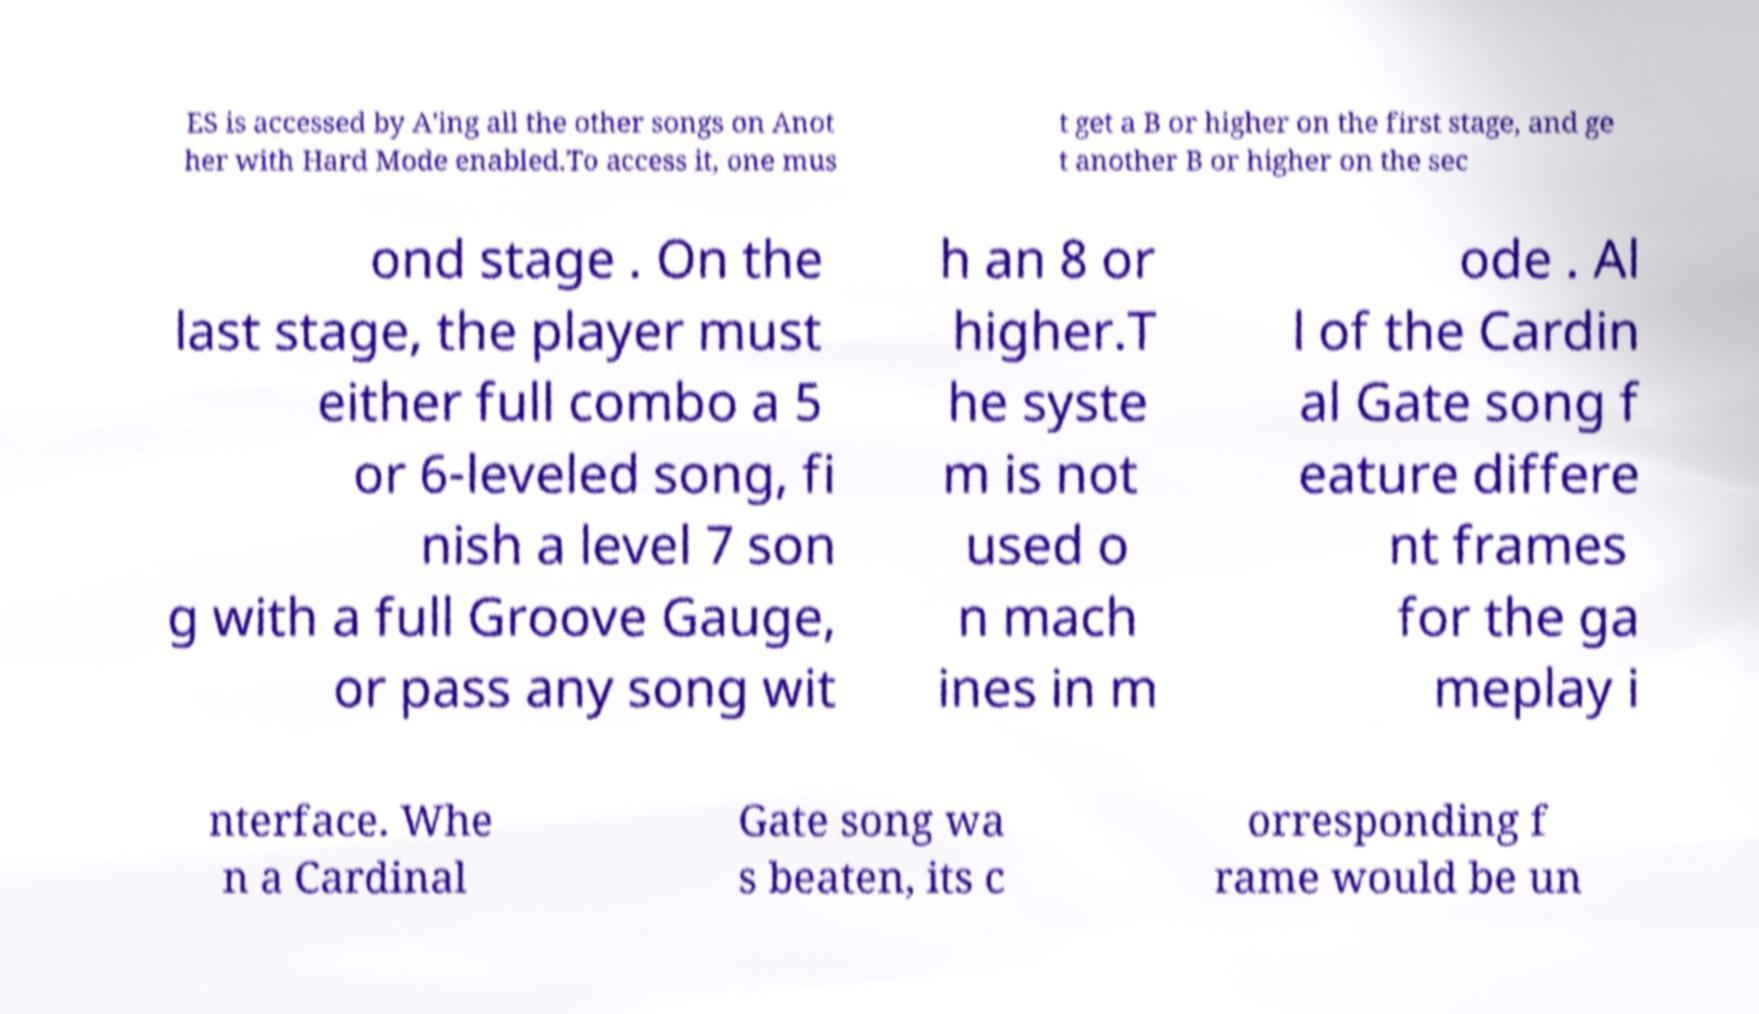Could you assist in decoding the text presented in this image and type it out clearly? ES is accessed by A'ing all the other songs on Anot her with Hard Mode enabled.To access it, one mus t get a B or higher on the first stage, and ge t another B or higher on the sec ond stage . On the last stage, the player must either full combo a 5 or 6-leveled song, fi nish a level 7 son g with a full Groove Gauge, or pass any song wit h an 8 or higher.T he syste m is not used o n mach ines in m ode . Al l of the Cardin al Gate song f eature differe nt frames for the ga meplay i nterface. Whe n a Cardinal Gate song wa s beaten, its c orresponding f rame would be un 